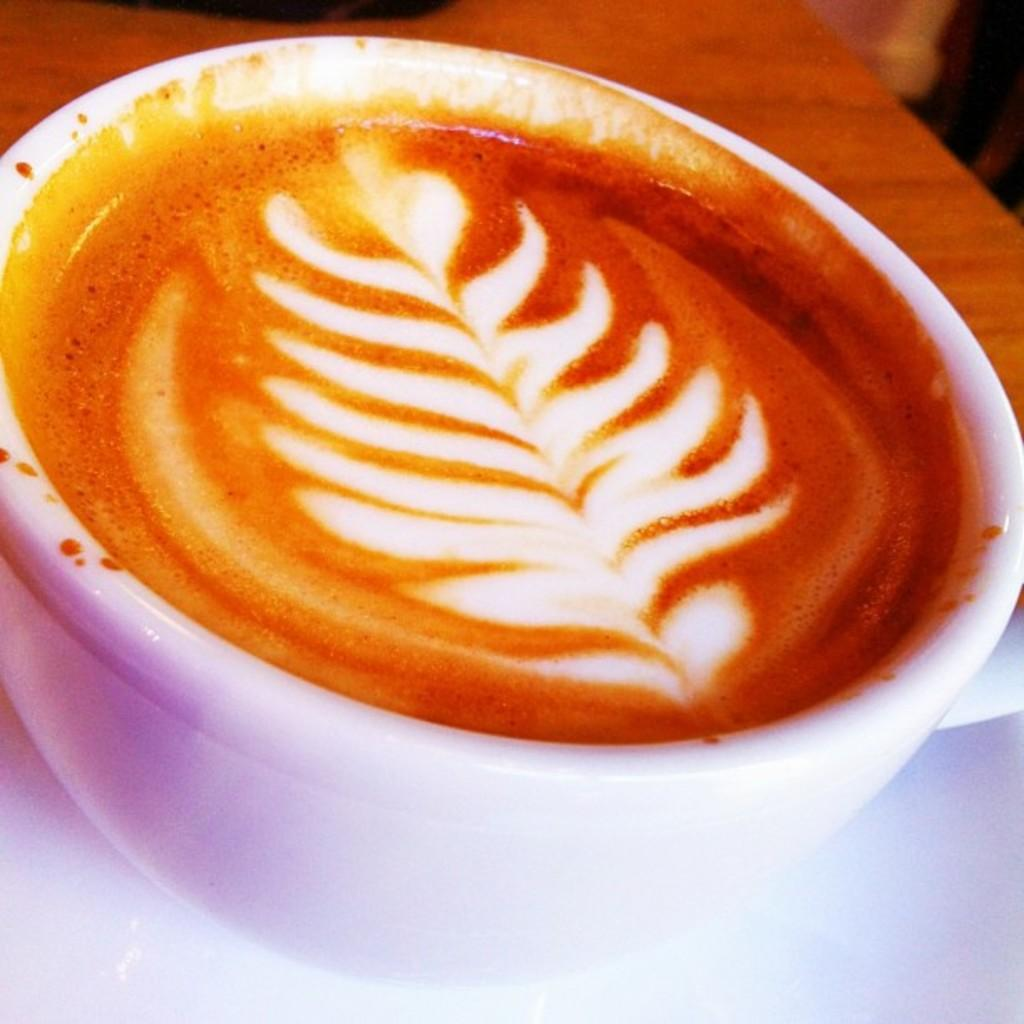What is in the cup that is visible in the image? There is a cup filled with coffee in the image. What design can be seen on the coffee? There is latte art on the coffee. What material does the table appear to be made of? The table appears to be made of wood. What is used to hold the cup in the image? There is a saucer in the image. What is the current status of the health of the coffee in the image? The image does not provide any information about the health of the coffee, as it is a still image and not a live video. 